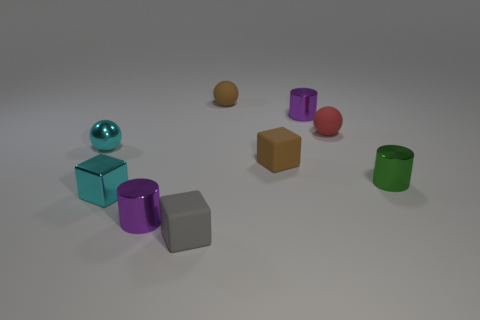How many tiny shiny things are the same color as the small metal cube?
Your answer should be very brief. 1. How many other things are there of the same material as the cyan ball?
Keep it short and to the point. 4. The purple object behind the small red rubber object has what shape?
Provide a succinct answer. Cylinder. There is a tiny ball that is behind the purple metallic thing that is right of the gray block; what is it made of?
Give a very brief answer. Rubber. Are there more tiny cyan blocks to the left of the brown ball than big shiny spheres?
Give a very brief answer. Yes. How many other things are the same color as the small metallic block?
Offer a terse response. 1. There is a gray matte object that is the same size as the green cylinder; what shape is it?
Your answer should be compact. Cube. There is a small cylinder on the left side of the purple metal cylinder to the right of the small gray rubber object; what number of small shiny spheres are in front of it?
Ensure brevity in your answer.  0. How many metal things are either small cyan objects or tiny purple objects?
Offer a very short reply. 4. What color is the tiny matte thing that is both in front of the tiny metal sphere and right of the gray cube?
Keep it short and to the point. Brown. 